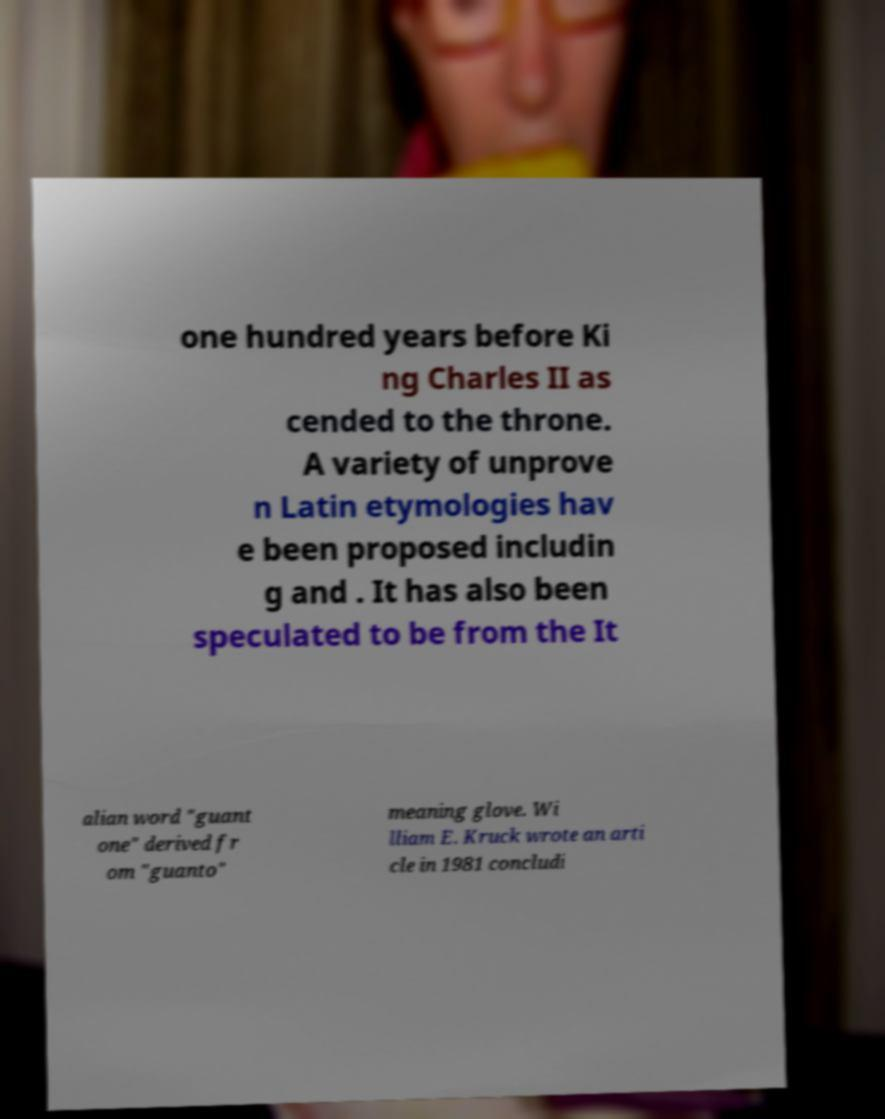Please identify and transcribe the text found in this image. one hundred years before Ki ng Charles II as cended to the throne. A variety of unprove n Latin etymologies hav e been proposed includin g and . It has also been speculated to be from the It alian word "guant one" derived fr om "guanto" meaning glove. Wi lliam E. Kruck wrote an arti cle in 1981 concludi 